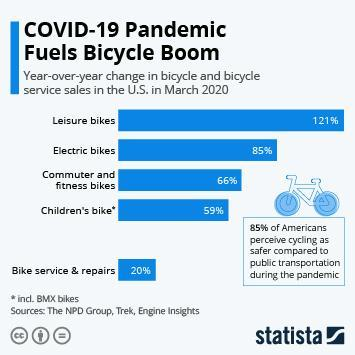What is the year-over-year change in the sales of commuter & fitness bikes in the U.S. in March 2020?
Answer the question with a short phrase. 66% Which bicycle type has showed growth rate of more than 100%  compared to the previous year in the U.S. in March 2020? Leisure bikes Which bicycle type has showed growth rate of less than 60% compared to the previous year in the U.S. in March 2020? Children's bike* What is the year-over-year change in the sales of electric bikes in the U.S. in March 2020? 85% 